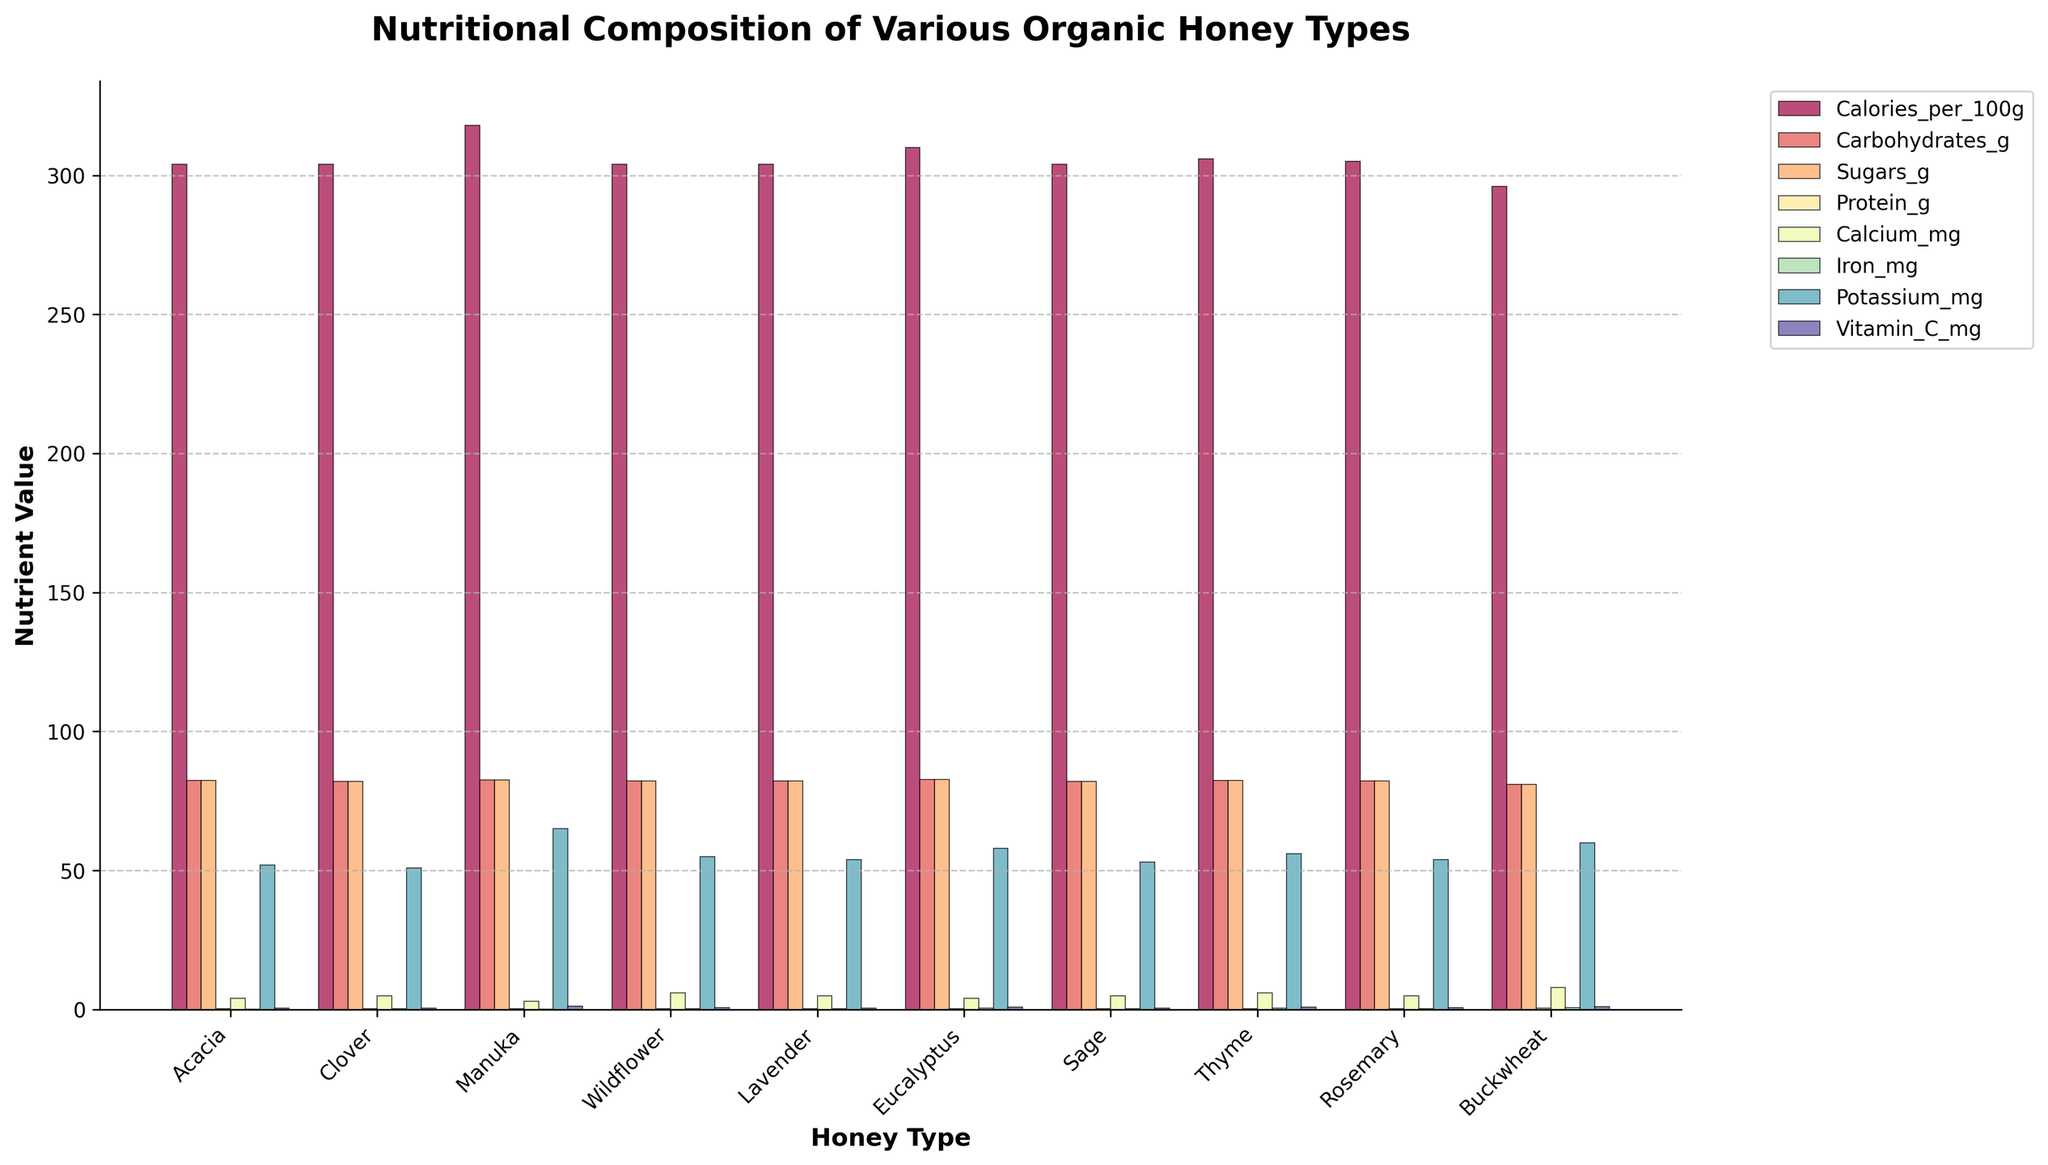Which type of honey has the highest calorie content? Manuka honey has the highest calorie content, which can be seen from the bar heights under "Calories_per_100g."
Answer: Manuka Which type of honey has the lowest sugar content? Buckwheat honey has the lowest sugar content, indicated by the shortest bar in the "Sugars_g" category.
Answer: Buckwheat How does the protein content of Eucalyptus compare to that of Thyme honey? Both Eucalyptus and Thyme honey have a protein content indicated by the bars under "Protein_g." Since both bars are equal in height, the protein content is the same.
Answer: Equal What is the difference between the Calcium content in Acacia and Buckwheat honey? For Acacia honey, the calcium content is 4 mg, and for Buckwheat honey, it is 8 mg. The difference is calculated as 8 - 4 = 4 mg.
Answer: 4 mg Which honey types have the same potassium content as Acacia honey? Acacia honey has a potassium content of 52 mg. The types with the same content can be identified by matching bar heights in the "Potassium_mg" category. Only Sage honey has a similar bar height.
Answer: Sage Which honey type is richest in Vitamin C? Manuka honey has the tallest bar under "Vitamin_C_mg," indicating it has the highest Vitamin C content.
Answer: Manuka What is the average carbohydrate content across all honey types? To find the average, sum up the carbohydrate content for all honey types and divide by the number of types: (82.4+82.1+82.5+82.3+82.2+82.7+82.0+82.4+82.3+81.0)/10 = 82.19 g.
Answer: 82.19 g Which honey type has the highest iron content, and how much is it? Buckwheat honey has the tallest bar in the "Iron_mg" category, indicating it has the highest iron content. The bar label indicates 0.7 mg.
Answer: Buckwheat, 0.7 mg Is there a significant difference between the Calories content of Clover and Lavender honey? Both Clover and Lavender honey have bars under "Calories_per_100g" that are very similar in height, indicating there is no significant difference in their calorie content. Both are around 304.
Answer: No significant difference 